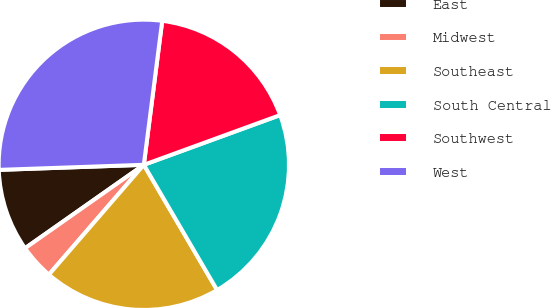Convert chart. <chart><loc_0><loc_0><loc_500><loc_500><pie_chart><fcel>East<fcel>Midwest<fcel>Southeast<fcel>South Central<fcel>Southwest<fcel>West<nl><fcel>9.19%<fcel>3.91%<fcel>19.77%<fcel>22.14%<fcel>17.41%<fcel>27.58%<nl></chart> 